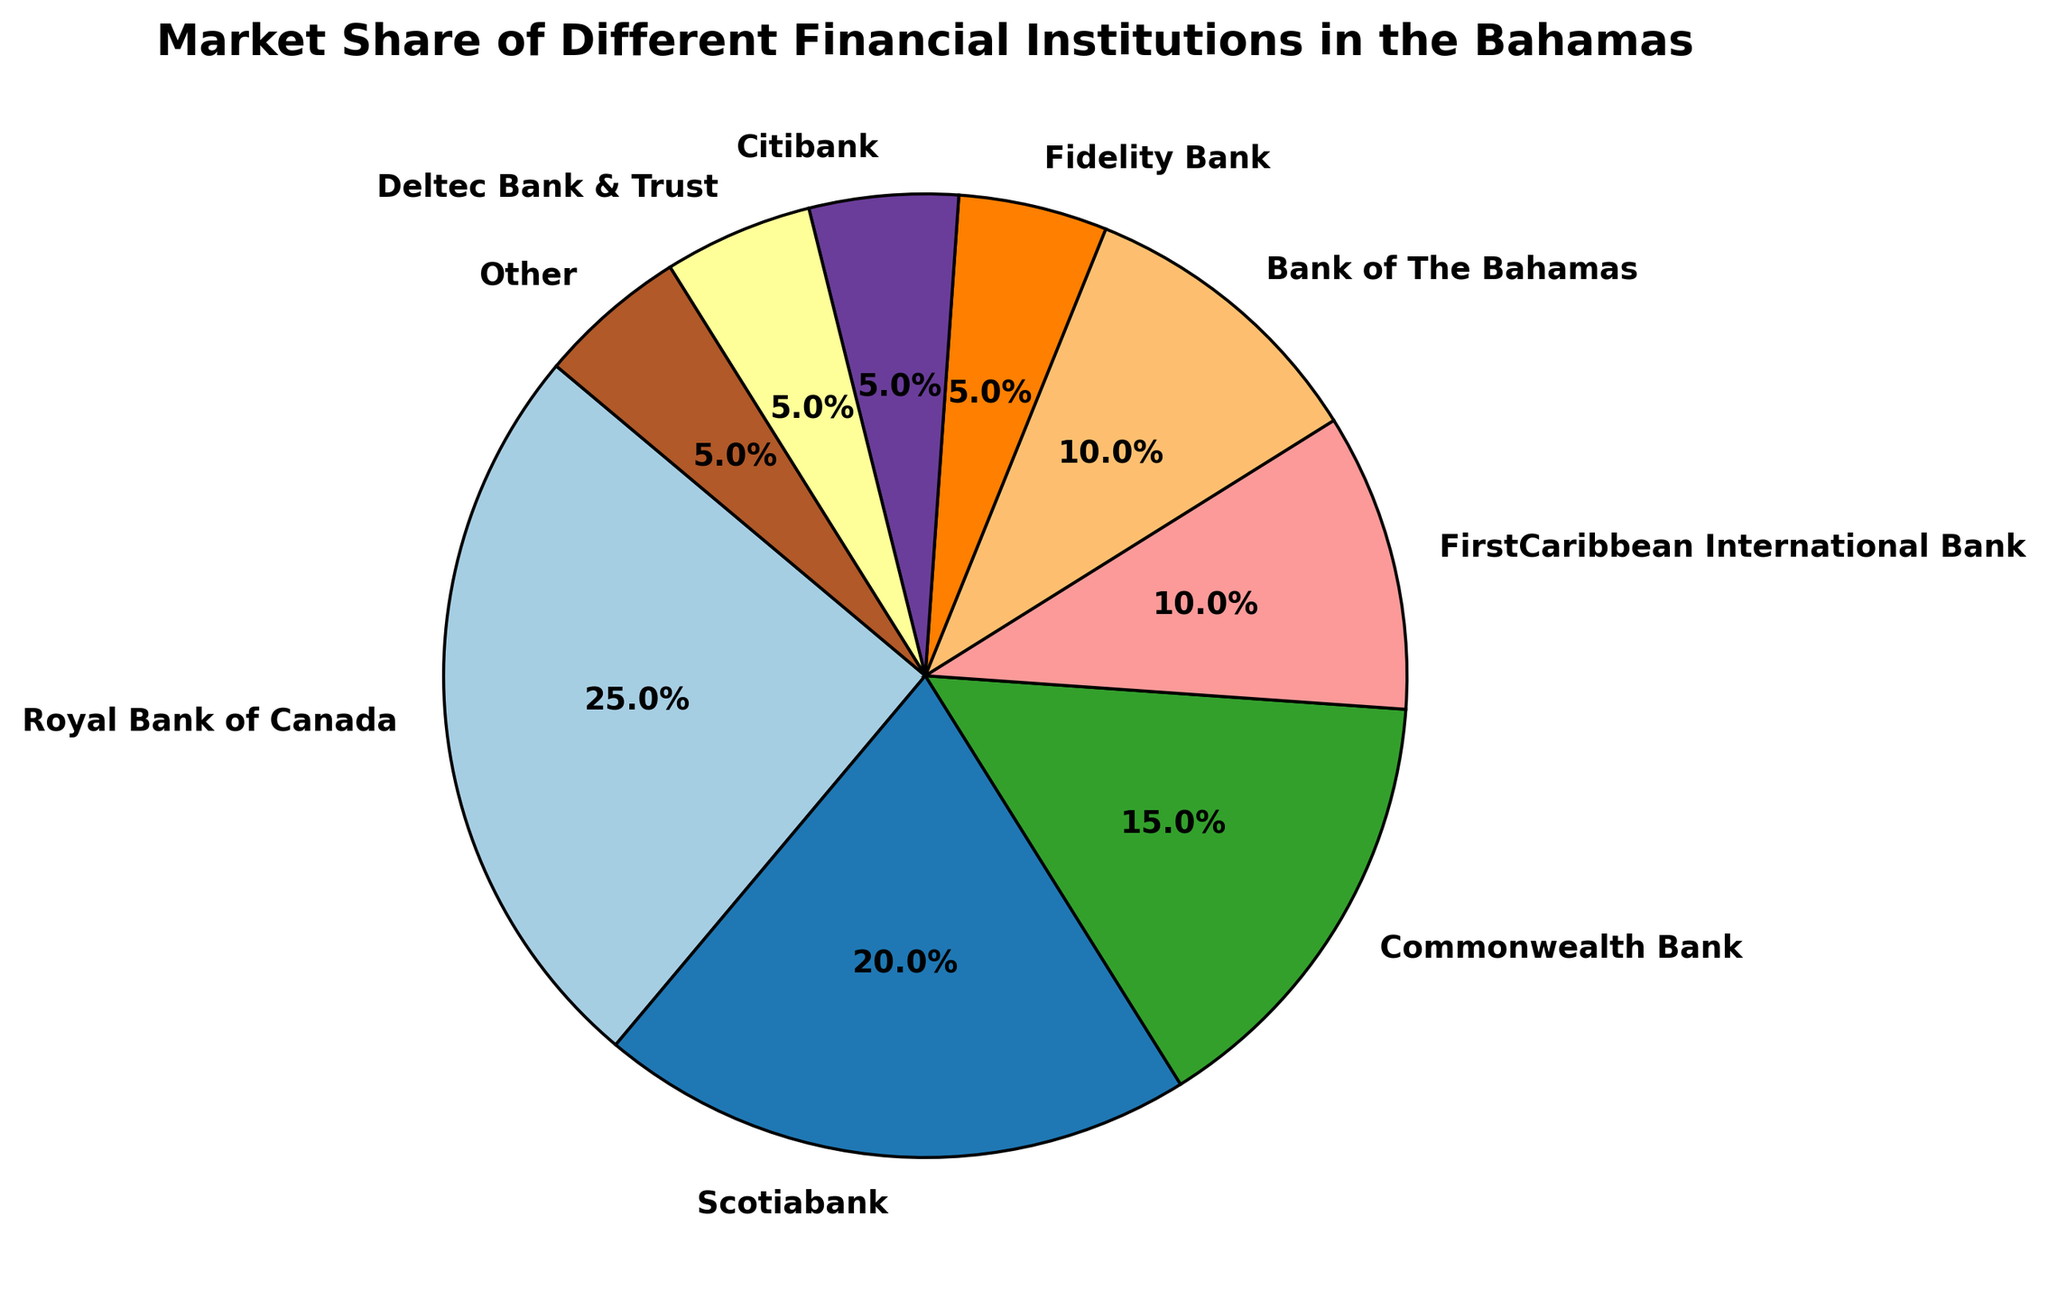Which institution has the largest market share? The figure lists the institutions and their corresponding market shares. By comparing these, the Royal Bank of Canada has the highest percentage with 25%.
Answer: Royal Bank of Canada Which institution ranks second in market share? By looking at the percentages, Scotiabank holds the second highest market share at 20%.
Answer: Scotiabank What is the combined market share of Commonwealth Bank, FirstCaribbean International Bank, and Fidelity Bank? Summing up the market shares: 15% (Commonwealth Bank) + 10% (FirstCaribbean International Bank) + 5% (Fidelity Bank) = 30%.
Answer: 30% What is the difference in market share between Scotiabank and FirstCaribbean International Bank? Subtracting the market share of FirstCaribbean from Scotiabank: 20% - 10% = 10%.
Answer: 10% Which institutions have equal market share? Comparing the percentages, Fidelity Bank, Citibank, Deltec Bank & Trust, and 'Other' each have a market share of 5%.
Answer: Fidelity Bank, Citibank, Deltec Bank & Trust, Other How much larger is the market share of the Royal Bank of Canada compared to Scotiabank? Subtracting the market share of Scotiabank from Royal Bank of Canada: 25% - 20% = 5%.
Answer: 5% What is the total market share of all institutions listed? Summing up all the given market shares: 25% (RBC) + 20% (Scotiabank) + 15% (Commonwealth) + 10% (FirstCaribbean) + 10% (Bank of The Bahamas) + 5% (Fidelity) + 5% (Citibank) + 5% (Deltec)  + 5% (Other) = 100%.
Answer: 100% Which institution has a market share closest to that of Bank of The Bahamas? The Bank of The Bahamas has a market share of 10%. Comparing this to others, FirstCaribbean International Bank also has a market share of 10%.
Answer: FirstCaribbean International Bank How do the market shares of Commonwealth Bank and Bank of The Bahamas compare? Commonwealth Bank has a market share of 15%, and Bank of The Bahamas has a market share of 10%. Therefore, Commonwealth Bank's market share is higher by 5%.
Answer: Commonwealth Bank's is higher by 5% What is the market share difference between the institution with the highest share and the combined share of the three smallest institutions? The Royal Bank of Canada has a 25% share. The three smallest shares are Fidelity Bank, Citibank, and Deltec Bank & Trust, each with 5%. Their combined share is 5% + 5% + 5% = 15%. The difference is 25% - 15% = 10%.
Answer: 10% 